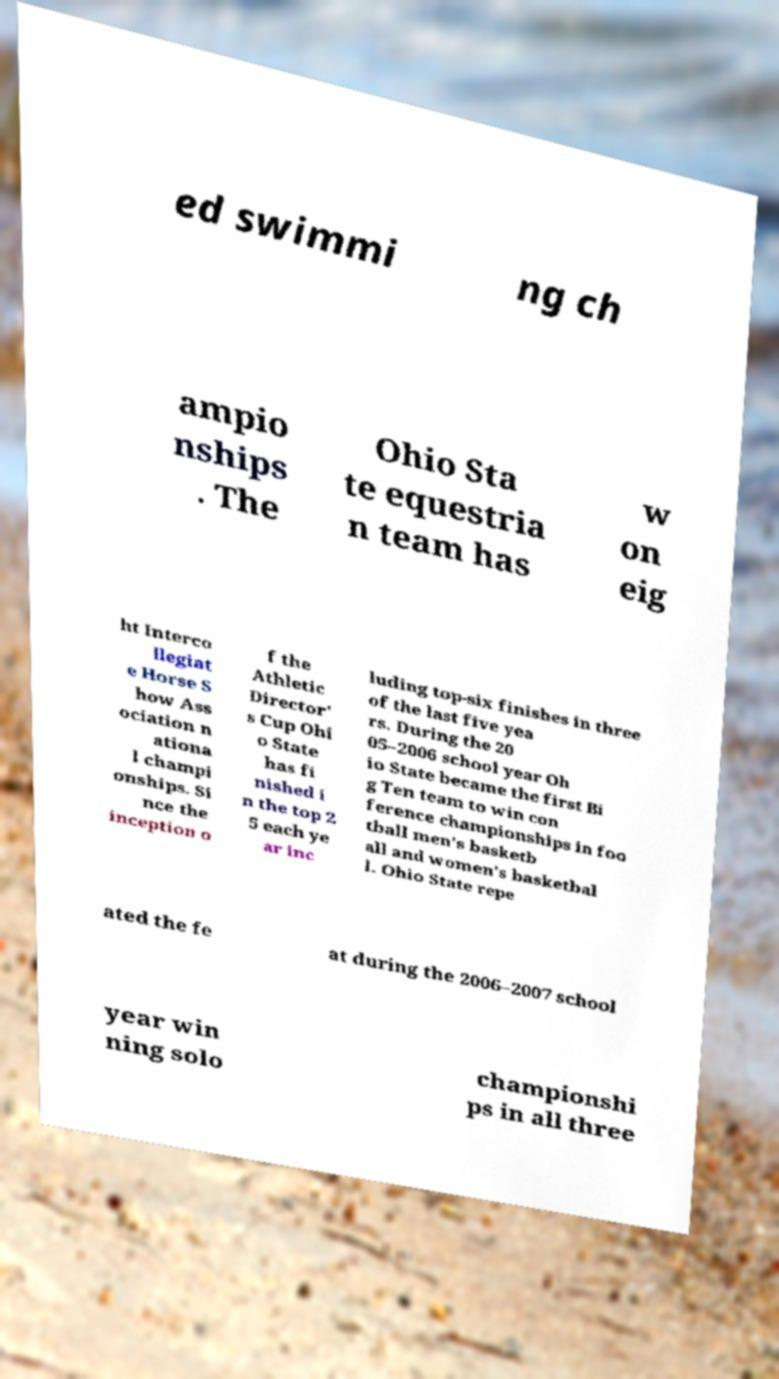Please read and relay the text visible in this image. What does it say? ed swimmi ng ch ampio nships . The Ohio Sta te equestria n team has w on eig ht Interco llegiat e Horse S how Ass ociation n ationa l champi onships. Si nce the inception o f the Athletic Director' s Cup Ohi o State has fi nished i n the top 2 5 each ye ar inc luding top-six finishes in three of the last five yea rs. During the 20 05–2006 school year Oh io State became the first Bi g Ten team to win con ference championships in foo tball men's basketb all and women's basketbal l. Ohio State repe ated the fe at during the 2006–2007 school year win ning solo championshi ps in all three 